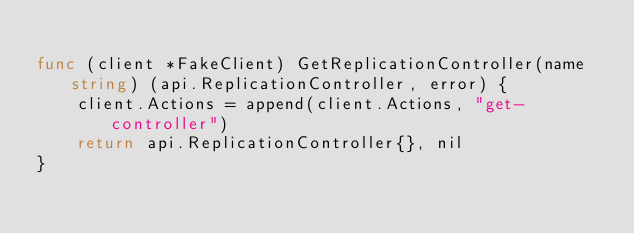Convert code to text. <code><loc_0><loc_0><loc_500><loc_500><_Go_>
func (client *FakeClient) GetReplicationController(name string) (api.ReplicationController, error) {
	client.Actions = append(client.Actions, "get-controller")
	return api.ReplicationController{}, nil
}
</code> 